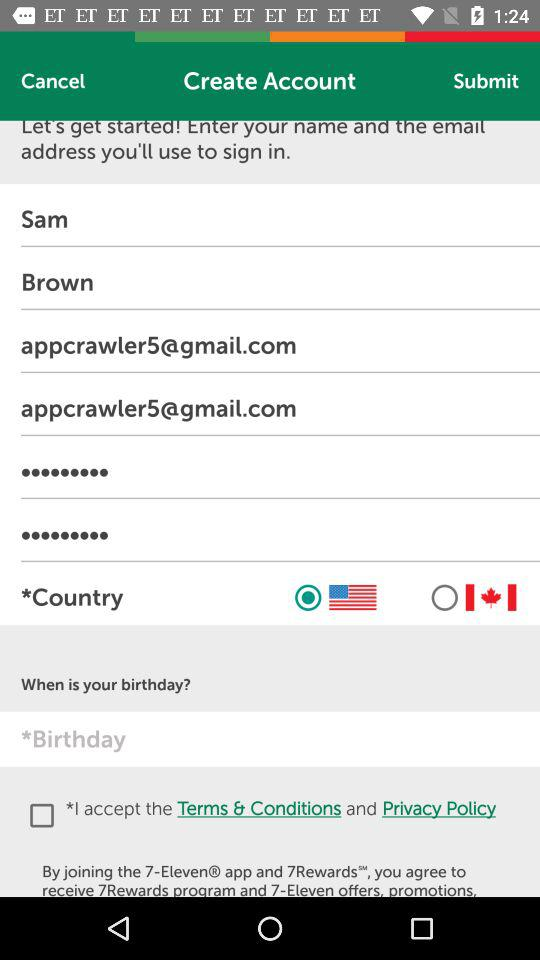What is the status of the option that includes acceptance to the "Terms & Conditions" and "Privacy Policy"? The status of the option that includes acceptance to the "Terms & Conditions" and "Privacy Policy" is "off". 